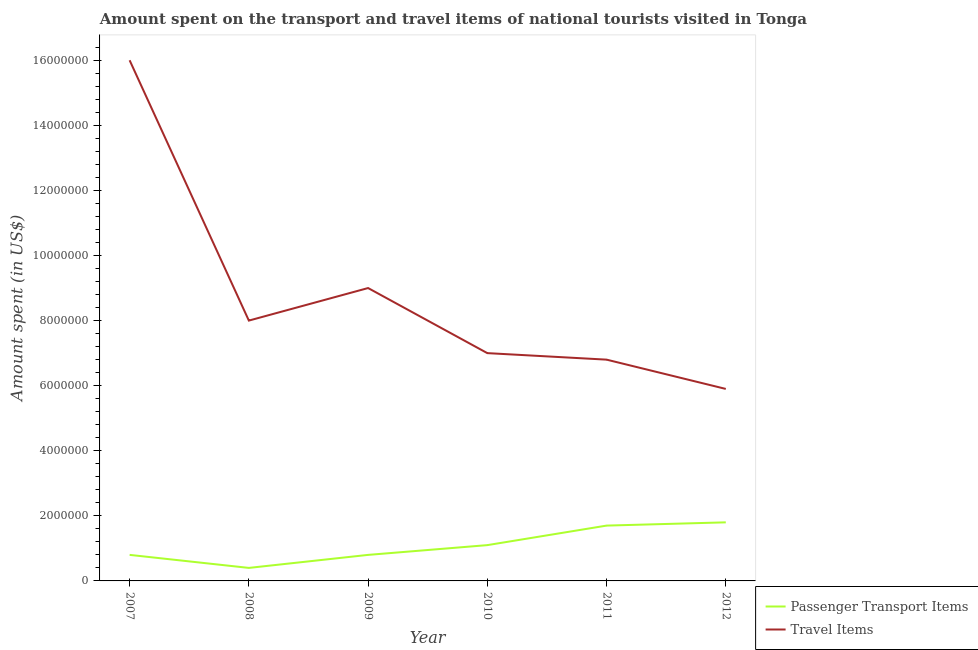Is the number of lines equal to the number of legend labels?
Your answer should be compact. Yes. What is the amount spent in travel items in 2008?
Provide a succinct answer. 8.00e+06. Across all years, what is the maximum amount spent on passenger transport items?
Offer a terse response. 1.80e+06. Across all years, what is the minimum amount spent on passenger transport items?
Offer a very short reply. 4.00e+05. In which year was the amount spent on passenger transport items maximum?
Make the answer very short. 2012. What is the total amount spent on passenger transport items in the graph?
Provide a short and direct response. 6.60e+06. What is the difference between the amount spent in travel items in 2010 and that in 2011?
Your answer should be compact. 2.00e+05. What is the difference between the amount spent on passenger transport items in 2010 and the amount spent in travel items in 2009?
Offer a very short reply. -7.90e+06. What is the average amount spent on passenger transport items per year?
Your response must be concise. 1.10e+06. In the year 2007, what is the difference between the amount spent in travel items and amount spent on passenger transport items?
Your answer should be very brief. 1.52e+07. What is the ratio of the amount spent on passenger transport items in 2008 to that in 2011?
Make the answer very short. 0.24. Is the amount spent in travel items in 2009 less than that in 2011?
Make the answer very short. No. Is the difference between the amount spent in travel items in 2008 and 2010 greater than the difference between the amount spent on passenger transport items in 2008 and 2010?
Your answer should be compact. Yes. What is the difference between the highest and the lowest amount spent in travel items?
Your answer should be compact. 1.01e+07. Does the amount spent on passenger transport items monotonically increase over the years?
Offer a very short reply. No. Is the amount spent in travel items strictly greater than the amount spent on passenger transport items over the years?
Offer a terse response. Yes. Is the amount spent in travel items strictly less than the amount spent on passenger transport items over the years?
Your response must be concise. No. How many years are there in the graph?
Make the answer very short. 6. What is the difference between two consecutive major ticks on the Y-axis?
Your response must be concise. 2.00e+06. Are the values on the major ticks of Y-axis written in scientific E-notation?
Keep it short and to the point. No. Where does the legend appear in the graph?
Your answer should be very brief. Bottom right. How many legend labels are there?
Your answer should be compact. 2. How are the legend labels stacked?
Make the answer very short. Vertical. What is the title of the graph?
Your answer should be very brief. Amount spent on the transport and travel items of national tourists visited in Tonga. What is the label or title of the Y-axis?
Offer a very short reply. Amount spent (in US$). What is the Amount spent (in US$) in Passenger Transport Items in 2007?
Your answer should be very brief. 8.00e+05. What is the Amount spent (in US$) of Travel Items in 2007?
Offer a very short reply. 1.60e+07. What is the Amount spent (in US$) of Passenger Transport Items in 2008?
Provide a short and direct response. 4.00e+05. What is the Amount spent (in US$) in Travel Items in 2008?
Provide a short and direct response. 8.00e+06. What is the Amount spent (in US$) in Passenger Transport Items in 2009?
Offer a very short reply. 8.00e+05. What is the Amount spent (in US$) in Travel Items in 2009?
Provide a succinct answer. 9.00e+06. What is the Amount spent (in US$) in Passenger Transport Items in 2010?
Keep it short and to the point. 1.10e+06. What is the Amount spent (in US$) of Passenger Transport Items in 2011?
Ensure brevity in your answer.  1.70e+06. What is the Amount spent (in US$) of Travel Items in 2011?
Your answer should be very brief. 6.80e+06. What is the Amount spent (in US$) in Passenger Transport Items in 2012?
Keep it short and to the point. 1.80e+06. What is the Amount spent (in US$) of Travel Items in 2012?
Offer a terse response. 5.90e+06. Across all years, what is the maximum Amount spent (in US$) of Passenger Transport Items?
Your response must be concise. 1.80e+06. Across all years, what is the maximum Amount spent (in US$) in Travel Items?
Keep it short and to the point. 1.60e+07. Across all years, what is the minimum Amount spent (in US$) of Passenger Transport Items?
Your answer should be very brief. 4.00e+05. Across all years, what is the minimum Amount spent (in US$) in Travel Items?
Make the answer very short. 5.90e+06. What is the total Amount spent (in US$) in Passenger Transport Items in the graph?
Your response must be concise. 6.60e+06. What is the total Amount spent (in US$) in Travel Items in the graph?
Keep it short and to the point. 5.27e+07. What is the difference between the Amount spent (in US$) in Passenger Transport Items in 2007 and that in 2008?
Keep it short and to the point. 4.00e+05. What is the difference between the Amount spent (in US$) of Passenger Transport Items in 2007 and that in 2009?
Your response must be concise. 0. What is the difference between the Amount spent (in US$) in Travel Items in 2007 and that in 2010?
Give a very brief answer. 9.00e+06. What is the difference between the Amount spent (in US$) in Passenger Transport Items in 2007 and that in 2011?
Ensure brevity in your answer.  -9.00e+05. What is the difference between the Amount spent (in US$) of Travel Items in 2007 and that in 2011?
Give a very brief answer. 9.20e+06. What is the difference between the Amount spent (in US$) of Travel Items in 2007 and that in 2012?
Your answer should be very brief. 1.01e+07. What is the difference between the Amount spent (in US$) of Passenger Transport Items in 2008 and that in 2009?
Your answer should be compact. -4.00e+05. What is the difference between the Amount spent (in US$) in Travel Items in 2008 and that in 2009?
Keep it short and to the point. -1.00e+06. What is the difference between the Amount spent (in US$) in Passenger Transport Items in 2008 and that in 2010?
Keep it short and to the point. -7.00e+05. What is the difference between the Amount spent (in US$) of Travel Items in 2008 and that in 2010?
Provide a succinct answer. 1.00e+06. What is the difference between the Amount spent (in US$) of Passenger Transport Items in 2008 and that in 2011?
Provide a succinct answer. -1.30e+06. What is the difference between the Amount spent (in US$) of Travel Items in 2008 and that in 2011?
Your answer should be compact. 1.20e+06. What is the difference between the Amount spent (in US$) in Passenger Transport Items in 2008 and that in 2012?
Make the answer very short. -1.40e+06. What is the difference between the Amount spent (in US$) of Travel Items in 2008 and that in 2012?
Your answer should be very brief. 2.10e+06. What is the difference between the Amount spent (in US$) of Travel Items in 2009 and that in 2010?
Your response must be concise. 2.00e+06. What is the difference between the Amount spent (in US$) of Passenger Transport Items in 2009 and that in 2011?
Keep it short and to the point. -9.00e+05. What is the difference between the Amount spent (in US$) in Travel Items in 2009 and that in 2011?
Provide a short and direct response. 2.20e+06. What is the difference between the Amount spent (in US$) of Travel Items in 2009 and that in 2012?
Provide a succinct answer. 3.10e+06. What is the difference between the Amount spent (in US$) of Passenger Transport Items in 2010 and that in 2011?
Give a very brief answer. -6.00e+05. What is the difference between the Amount spent (in US$) of Passenger Transport Items in 2010 and that in 2012?
Offer a terse response. -7.00e+05. What is the difference between the Amount spent (in US$) in Travel Items in 2010 and that in 2012?
Offer a terse response. 1.10e+06. What is the difference between the Amount spent (in US$) of Passenger Transport Items in 2011 and that in 2012?
Your answer should be compact. -1.00e+05. What is the difference between the Amount spent (in US$) of Travel Items in 2011 and that in 2012?
Ensure brevity in your answer.  9.00e+05. What is the difference between the Amount spent (in US$) in Passenger Transport Items in 2007 and the Amount spent (in US$) in Travel Items in 2008?
Your response must be concise. -7.20e+06. What is the difference between the Amount spent (in US$) in Passenger Transport Items in 2007 and the Amount spent (in US$) in Travel Items in 2009?
Make the answer very short. -8.20e+06. What is the difference between the Amount spent (in US$) of Passenger Transport Items in 2007 and the Amount spent (in US$) of Travel Items in 2010?
Provide a short and direct response. -6.20e+06. What is the difference between the Amount spent (in US$) of Passenger Transport Items in 2007 and the Amount spent (in US$) of Travel Items in 2011?
Offer a terse response. -6.00e+06. What is the difference between the Amount spent (in US$) of Passenger Transport Items in 2007 and the Amount spent (in US$) of Travel Items in 2012?
Offer a terse response. -5.10e+06. What is the difference between the Amount spent (in US$) of Passenger Transport Items in 2008 and the Amount spent (in US$) of Travel Items in 2009?
Your answer should be compact. -8.60e+06. What is the difference between the Amount spent (in US$) in Passenger Transport Items in 2008 and the Amount spent (in US$) in Travel Items in 2010?
Your answer should be very brief. -6.60e+06. What is the difference between the Amount spent (in US$) in Passenger Transport Items in 2008 and the Amount spent (in US$) in Travel Items in 2011?
Offer a terse response. -6.40e+06. What is the difference between the Amount spent (in US$) in Passenger Transport Items in 2008 and the Amount spent (in US$) in Travel Items in 2012?
Your answer should be very brief. -5.50e+06. What is the difference between the Amount spent (in US$) of Passenger Transport Items in 2009 and the Amount spent (in US$) of Travel Items in 2010?
Offer a terse response. -6.20e+06. What is the difference between the Amount spent (in US$) of Passenger Transport Items in 2009 and the Amount spent (in US$) of Travel Items in 2011?
Your answer should be compact. -6.00e+06. What is the difference between the Amount spent (in US$) in Passenger Transport Items in 2009 and the Amount spent (in US$) in Travel Items in 2012?
Offer a terse response. -5.10e+06. What is the difference between the Amount spent (in US$) in Passenger Transport Items in 2010 and the Amount spent (in US$) in Travel Items in 2011?
Give a very brief answer. -5.70e+06. What is the difference between the Amount spent (in US$) in Passenger Transport Items in 2010 and the Amount spent (in US$) in Travel Items in 2012?
Keep it short and to the point. -4.80e+06. What is the difference between the Amount spent (in US$) in Passenger Transport Items in 2011 and the Amount spent (in US$) in Travel Items in 2012?
Provide a short and direct response. -4.20e+06. What is the average Amount spent (in US$) in Passenger Transport Items per year?
Keep it short and to the point. 1.10e+06. What is the average Amount spent (in US$) of Travel Items per year?
Ensure brevity in your answer.  8.78e+06. In the year 2007, what is the difference between the Amount spent (in US$) in Passenger Transport Items and Amount spent (in US$) in Travel Items?
Your answer should be compact. -1.52e+07. In the year 2008, what is the difference between the Amount spent (in US$) in Passenger Transport Items and Amount spent (in US$) in Travel Items?
Your answer should be compact. -7.60e+06. In the year 2009, what is the difference between the Amount spent (in US$) of Passenger Transport Items and Amount spent (in US$) of Travel Items?
Ensure brevity in your answer.  -8.20e+06. In the year 2010, what is the difference between the Amount spent (in US$) in Passenger Transport Items and Amount spent (in US$) in Travel Items?
Provide a succinct answer. -5.90e+06. In the year 2011, what is the difference between the Amount spent (in US$) in Passenger Transport Items and Amount spent (in US$) in Travel Items?
Your answer should be compact. -5.10e+06. In the year 2012, what is the difference between the Amount spent (in US$) in Passenger Transport Items and Amount spent (in US$) in Travel Items?
Keep it short and to the point. -4.10e+06. What is the ratio of the Amount spent (in US$) in Passenger Transport Items in 2007 to that in 2008?
Your answer should be very brief. 2. What is the ratio of the Amount spent (in US$) in Travel Items in 2007 to that in 2008?
Your answer should be compact. 2. What is the ratio of the Amount spent (in US$) of Passenger Transport Items in 2007 to that in 2009?
Offer a very short reply. 1. What is the ratio of the Amount spent (in US$) of Travel Items in 2007 to that in 2009?
Provide a short and direct response. 1.78. What is the ratio of the Amount spent (in US$) of Passenger Transport Items in 2007 to that in 2010?
Offer a very short reply. 0.73. What is the ratio of the Amount spent (in US$) of Travel Items in 2007 to that in 2010?
Offer a very short reply. 2.29. What is the ratio of the Amount spent (in US$) of Passenger Transport Items in 2007 to that in 2011?
Keep it short and to the point. 0.47. What is the ratio of the Amount spent (in US$) in Travel Items in 2007 to that in 2011?
Give a very brief answer. 2.35. What is the ratio of the Amount spent (in US$) of Passenger Transport Items in 2007 to that in 2012?
Ensure brevity in your answer.  0.44. What is the ratio of the Amount spent (in US$) in Travel Items in 2007 to that in 2012?
Keep it short and to the point. 2.71. What is the ratio of the Amount spent (in US$) in Passenger Transport Items in 2008 to that in 2010?
Keep it short and to the point. 0.36. What is the ratio of the Amount spent (in US$) in Travel Items in 2008 to that in 2010?
Provide a succinct answer. 1.14. What is the ratio of the Amount spent (in US$) in Passenger Transport Items in 2008 to that in 2011?
Your answer should be very brief. 0.24. What is the ratio of the Amount spent (in US$) in Travel Items in 2008 to that in 2011?
Your response must be concise. 1.18. What is the ratio of the Amount spent (in US$) in Passenger Transport Items in 2008 to that in 2012?
Provide a short and direct response. 0.22. What is the ratio of the Amount spent (in US$) in Travel Items in 2008 to that in 2012?
Offer a very short reply. 1.36. What is the ratio of the Amount spent (in US$) in Passenger Transport Items in 2009 to that in 2010?
Your response must be concise. 0.73. What is the ratio of the Amount spent (in US$) in Passenger Transport Items in 2009 to that in 2011?
Provide a succinct answer. 0.47. What is the ratio of the Amount spent (in US$) of Travel Items in 2009 to that in 2011?
Keep it short and to the point. 1.32. What is the ratio of the Amount spent (in US$) of Passenger Transport Items in 2009 to that in 2012?
Your response must be concise. 0.44. What is the ratio of the Amount spent (in US$) in Travel Items in 2009 to that in 2012?
Provide a short and direct response. 1.53. What is the ratio of the Amount spent (in US$) of Passenger Transport Items in 2010 to that in 2011?
Ensure brevity in your answer.  0.65. What is the ratio of the Amount spent (in US$) in Travel Items in 2010 to that in 2011?
Your answer should be very brief. 1.03. What is the ratio of the Amount spent (in US$) in Passenger Transport Items in 2010 to that in 2012?
Offer a very short reply. 0.61. What is the ratio of the Amount spent (in US$) in Travel Items in 2010 to that in 2012?
Offer a very short reply. 1.19. What is the ratio of the Amount spent (in US$) of Passenger Transport Items in 2011 to that in 2012?
Offer a very short reply. 0.94. What is the ratio of the Amount spent (in US$) in Travel Items in 2011 to that in 2012?
Your answer should be very brief. 1.15. What is the difference between the highest and the lowest Amount spent (in US$) in Passenger Transport Items?
Your answer should be very brief. 1.40e+06. What is the difference between the highest and the lowest Amount spent (in US$) of Travel Items?
Give a very brief answer. 1.01e+07. 